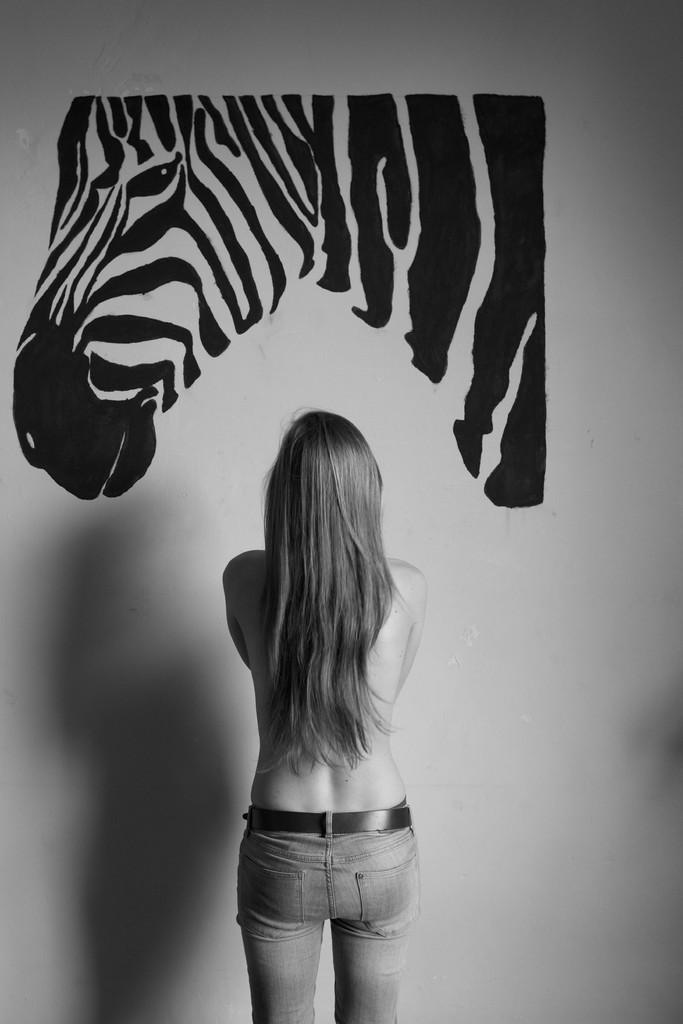Could you give a brief overview of what you see in this image? It is a black and white image. In this picture, we can see a woman is standing near the wall. On the wall, we can see the picture of a zebra. 